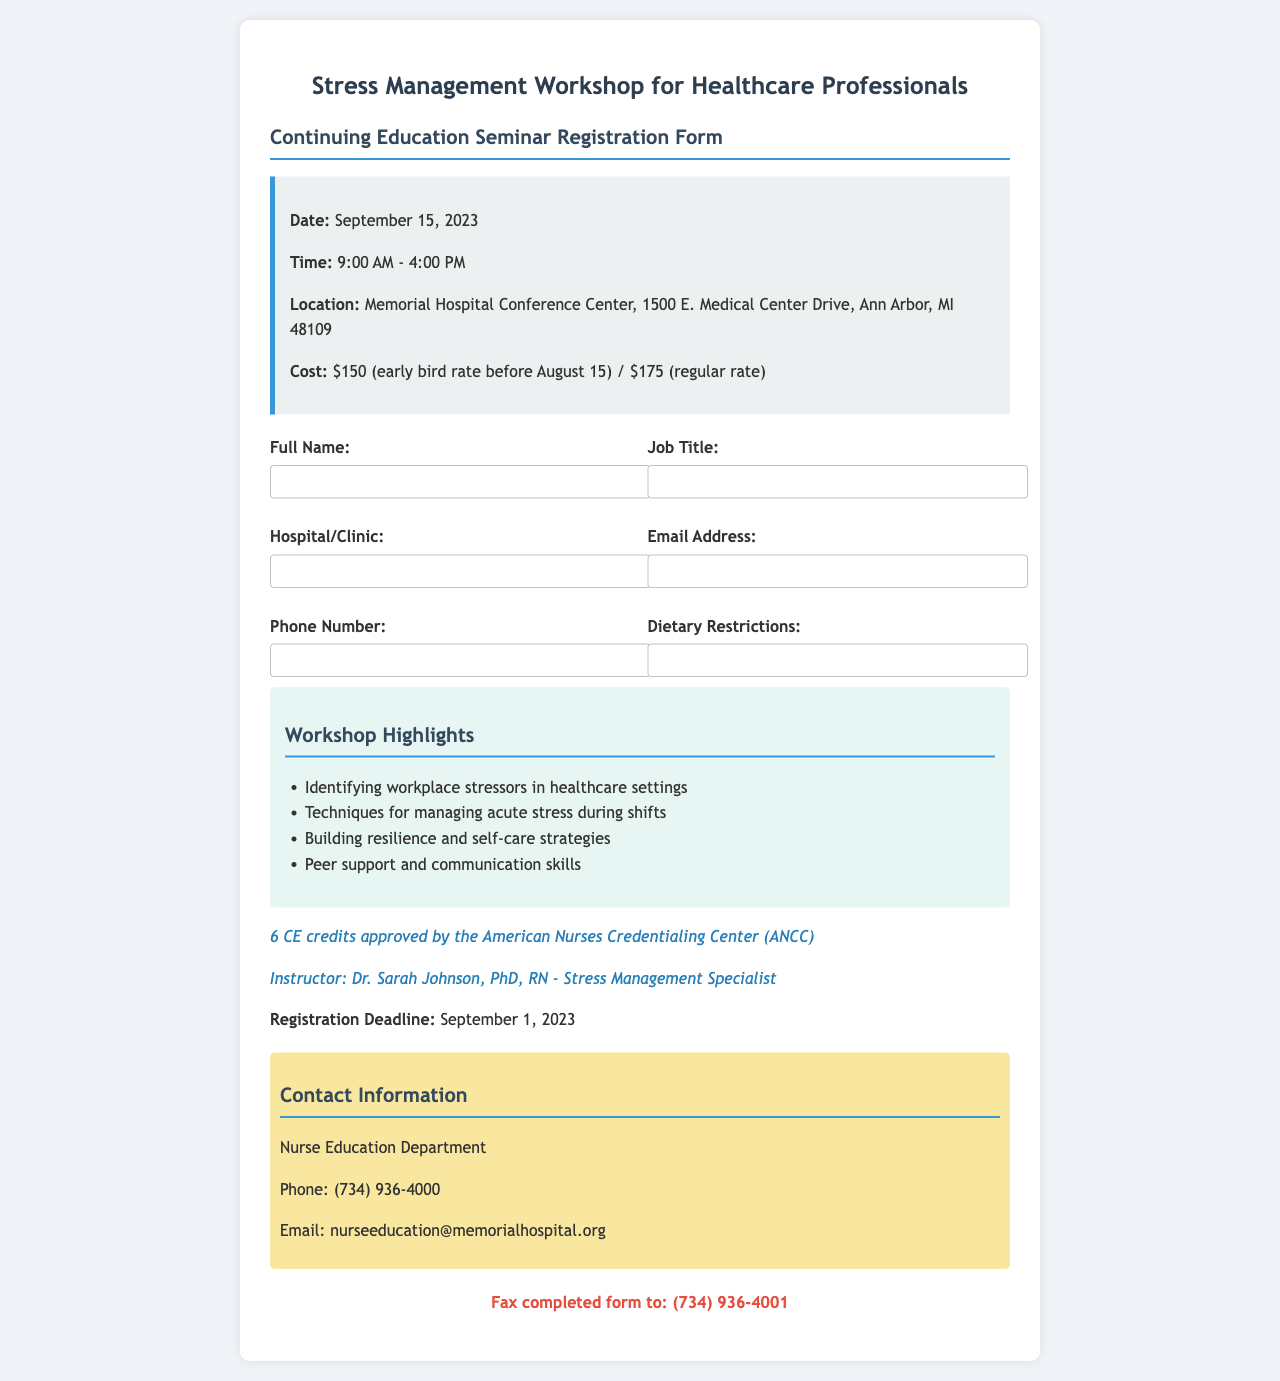What is the date of the workshop? The date of the workshop is mentioned in the event details section of the document.
Answer: September 15, 2023 What are the early bird and regular rates? The document lists the cost of attending the workshop under the event details.
Answer: $150 (early bird rate before August 15) / $175 (regular rate) Who is the instructor of the workshop? The instructor's name and title are provided in the document.
Answer: Dr. Sarah Johnson, PhD, RN What is the total number of CE credits offered? The number of CE credits is stated in the highlights section of the document.
Answer: 6 CE credits What is the registration deadline? The deadline for registration can be found in a separate section of the document.
Answer: September 1, 2023 What is the location of the workshop? The location is specified in the event details section.
Answer: Memorial Hospital Conference Center, 1500 E. Medical Center Drive, Ann Arbor, MI 48109 What should completed forms be faxed to? The fax number for submitting completed forms is listed in the footer of the document.
Answer: (734) 936-4001 List one technique being taught for managing stress. The document includes highlights of the workshop that list techniques.
Answer: Techniques for managing acute stress during shifts What type of professionals is the workshop tailored for? The title of the workshop indicates the intended audience.
Answer: Healthcare professionals 